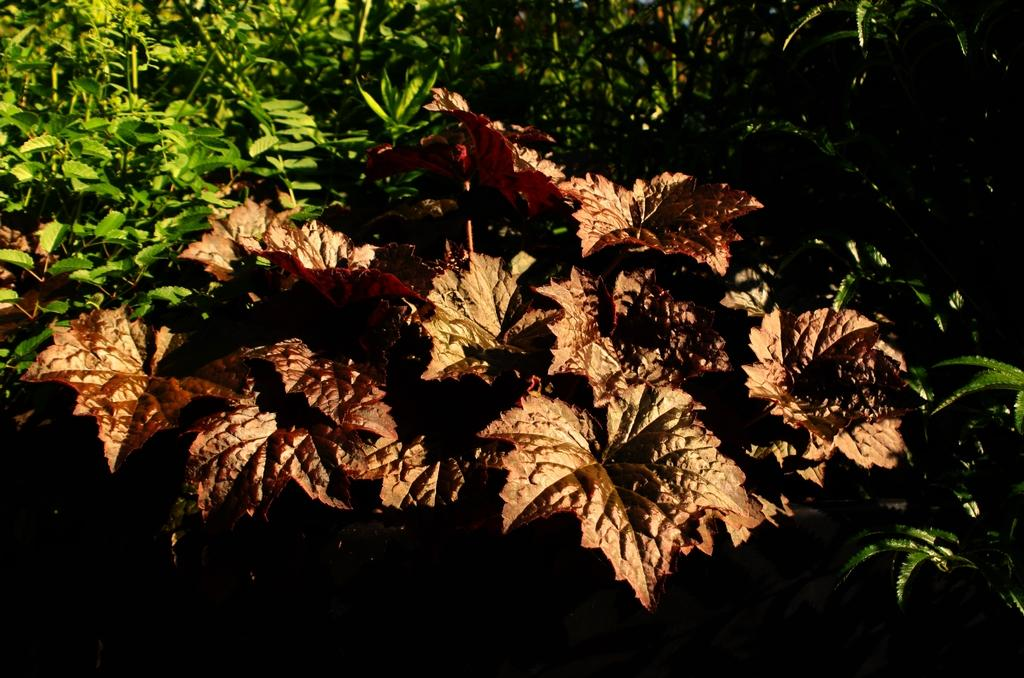What type of vegetation can be seen in the image? There are leaves in the image. What can be seen in the background of the image? There are plants in the background of the image. What type of whistle is being used to control the plants in the image? There is no whistle or control mechanism present in the image; it simply features leaves and plants. 